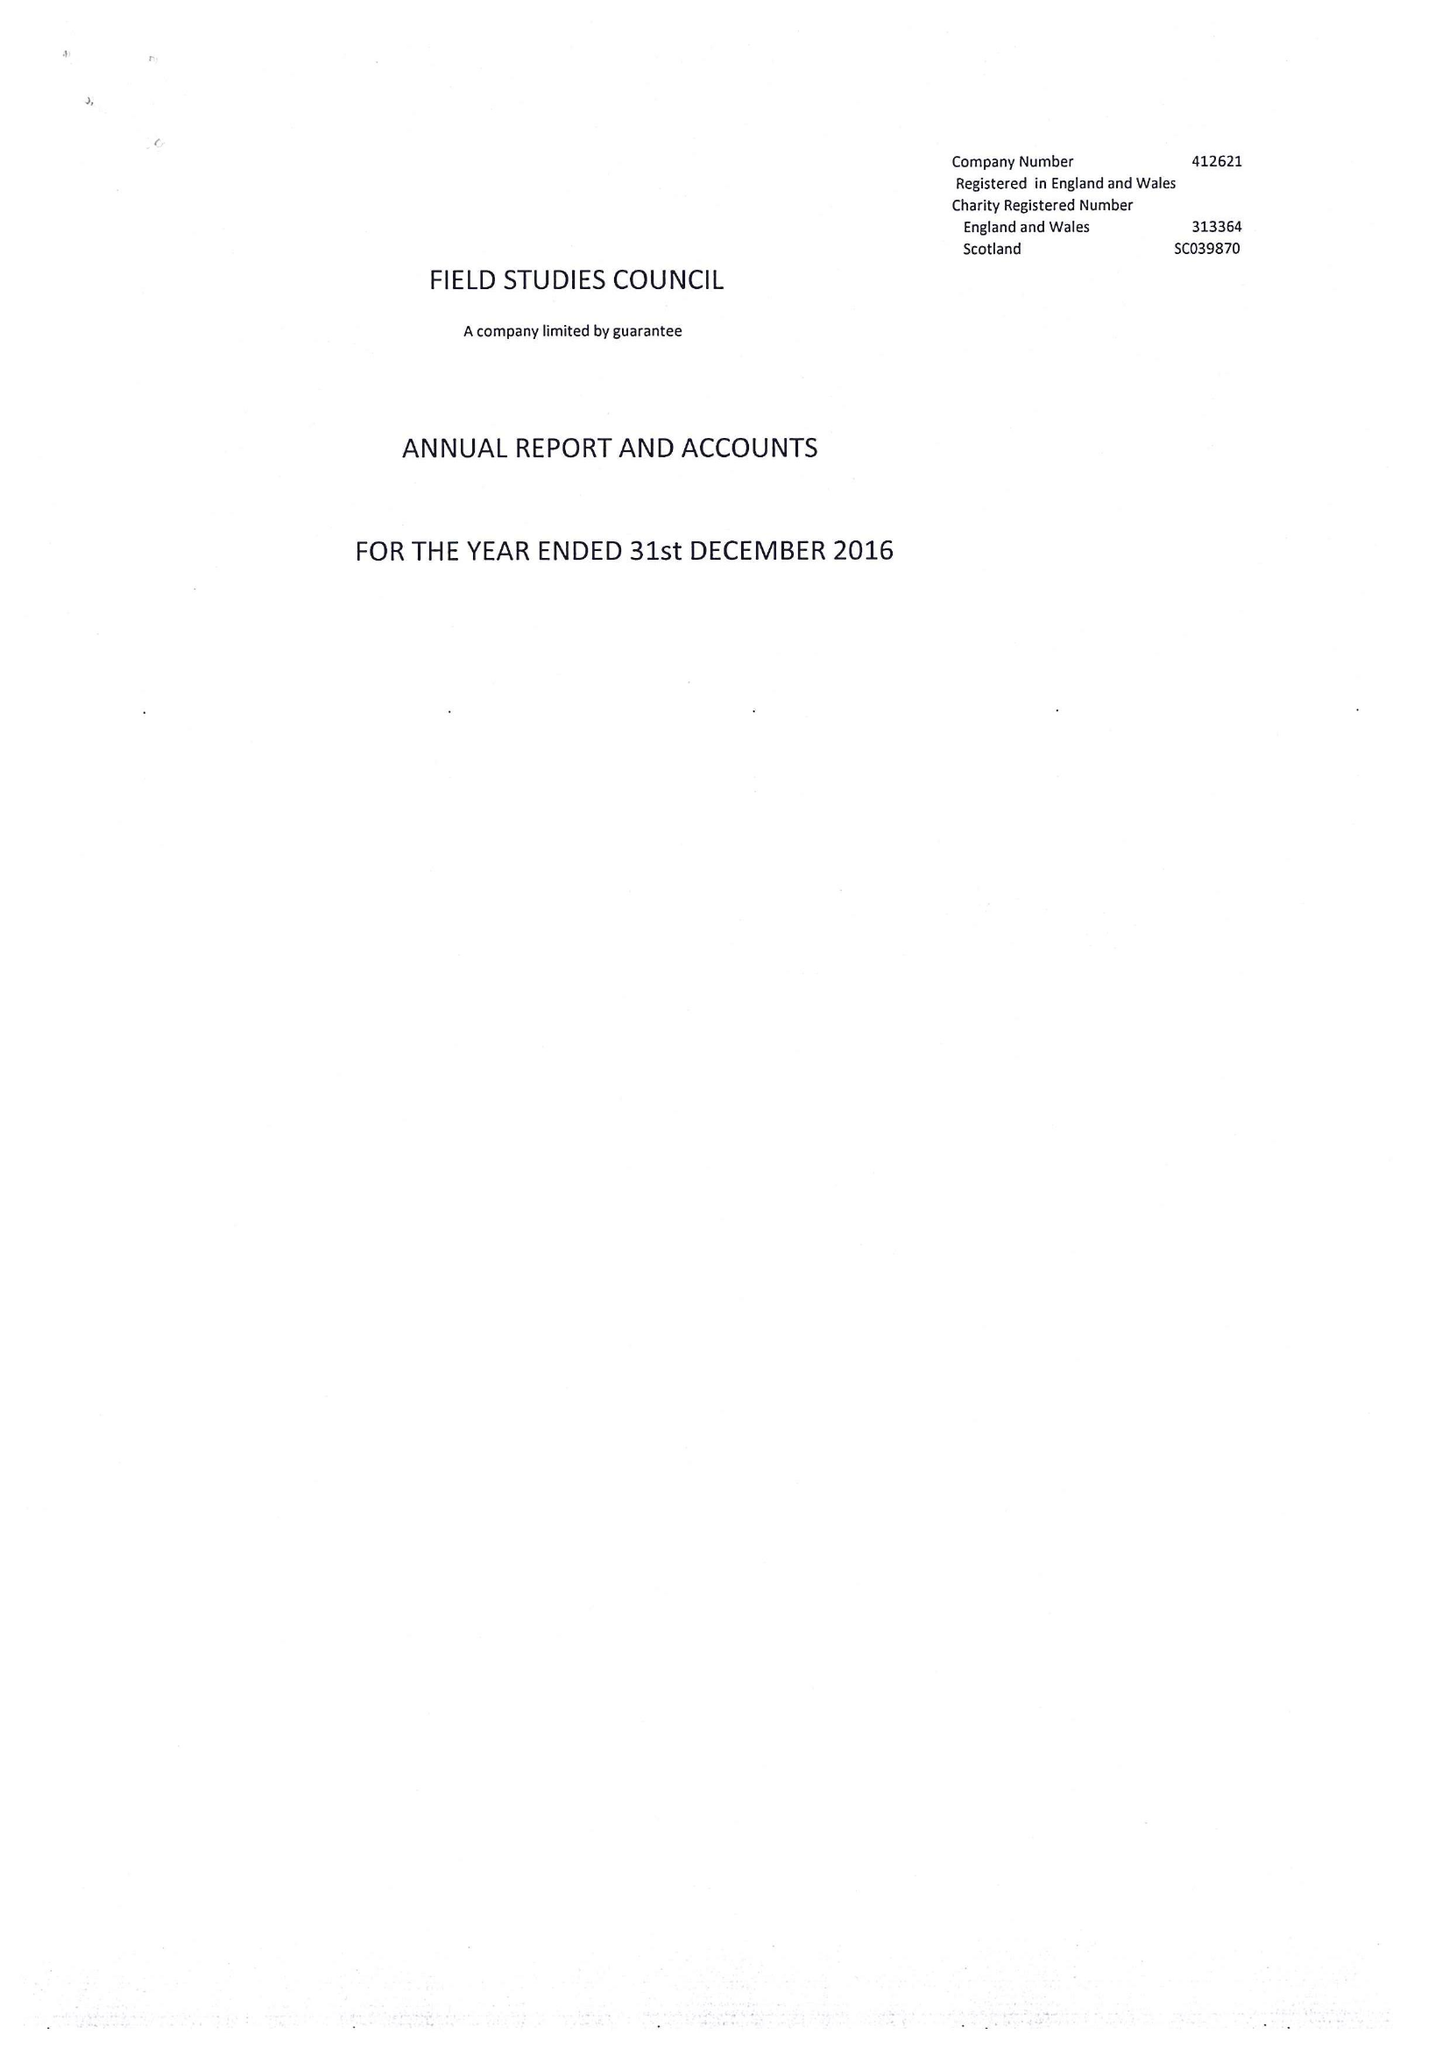What is the value for the income_annually_in_british_pounds?
Answer the question using a single word or phrase. 17795408.00 